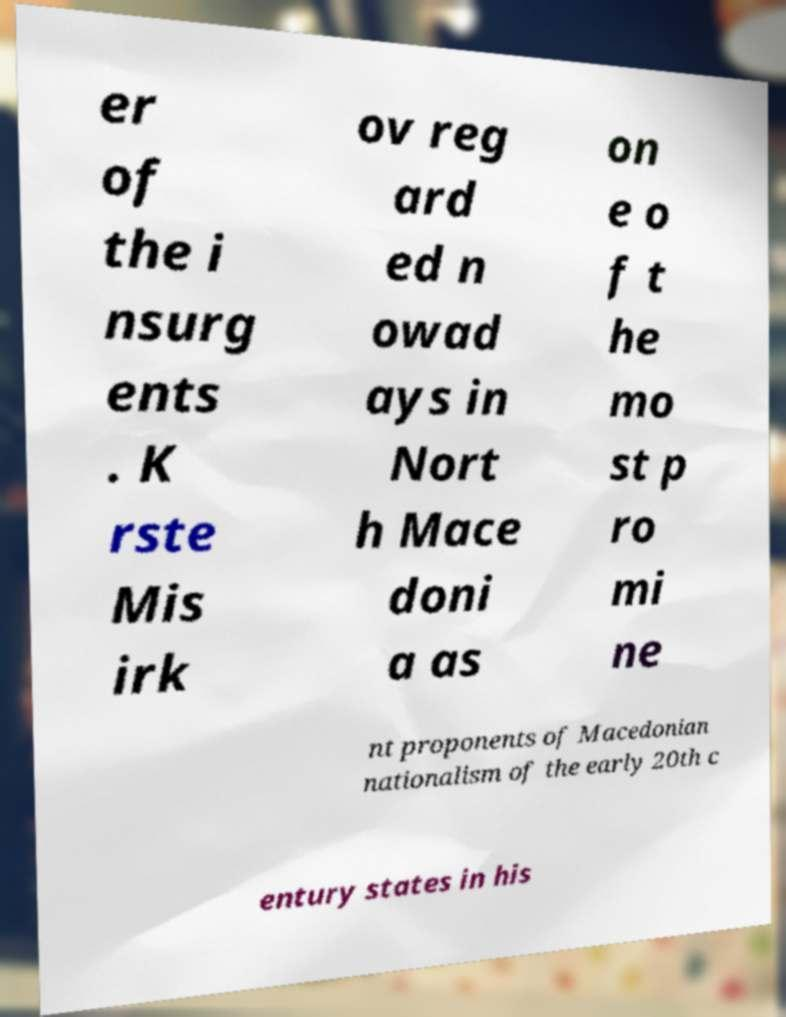I need the written content from this picture converted into text. Can you do that? er of the i nsurg ents . K rste Mis irk ov reg ard ed n owad ays in Nort h Mace doni a as on e o f t he mo st p ro mi ne nt proponents of Macedonian nationalism of the early 20th c entury states in his 